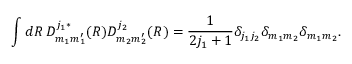<formula> <loc_0><loc_0><loc_500><loc_500>\int d R \, D _ { m _ { 1 } m _ { 1 } ^ { \prime } } ^ { j _ { 1 } \ast } ( R ) D _ { m _ { 2 } m _ { 2 } ^ { \prime } } ^ { j _ { 2 } } ( R ) = \frac { 1 } { 2 j _ { 1 } + 1 } \delta _ { j _ { 1 } j _ { 2 } } \delta _ { m _ { 1 } m _ { 2 } } \delta _ { m _ { 1 } m _ { 2 } } .</formula> 